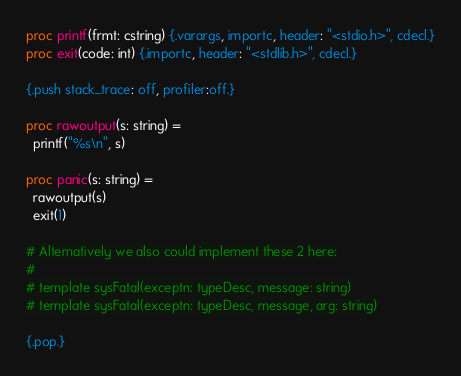<code> <loc_0><loc_0><loc_500><loc_500><_Nim_>
proc printf(frmt: cstring) {.varargs, importc, header: "<stdio.h>", cdecl.}
proc exit(code: int) {.importc, header: "<stdlib.h>", cdecl.}

{.push stack_trace: off, profiler:off.}

proc rawoutput(s: string) =
  printf("%s\n", s)

proc panic(s: string) =
  rawoutput(s)
  exit(1)

# Alternatively we also could implement these 2 here:
#
# template sysFatal(exceptn: typeDesc, message: string)
# template sysFatal(exceptn: typeDesc, message, arg: string)

{.pop.}
</code> 